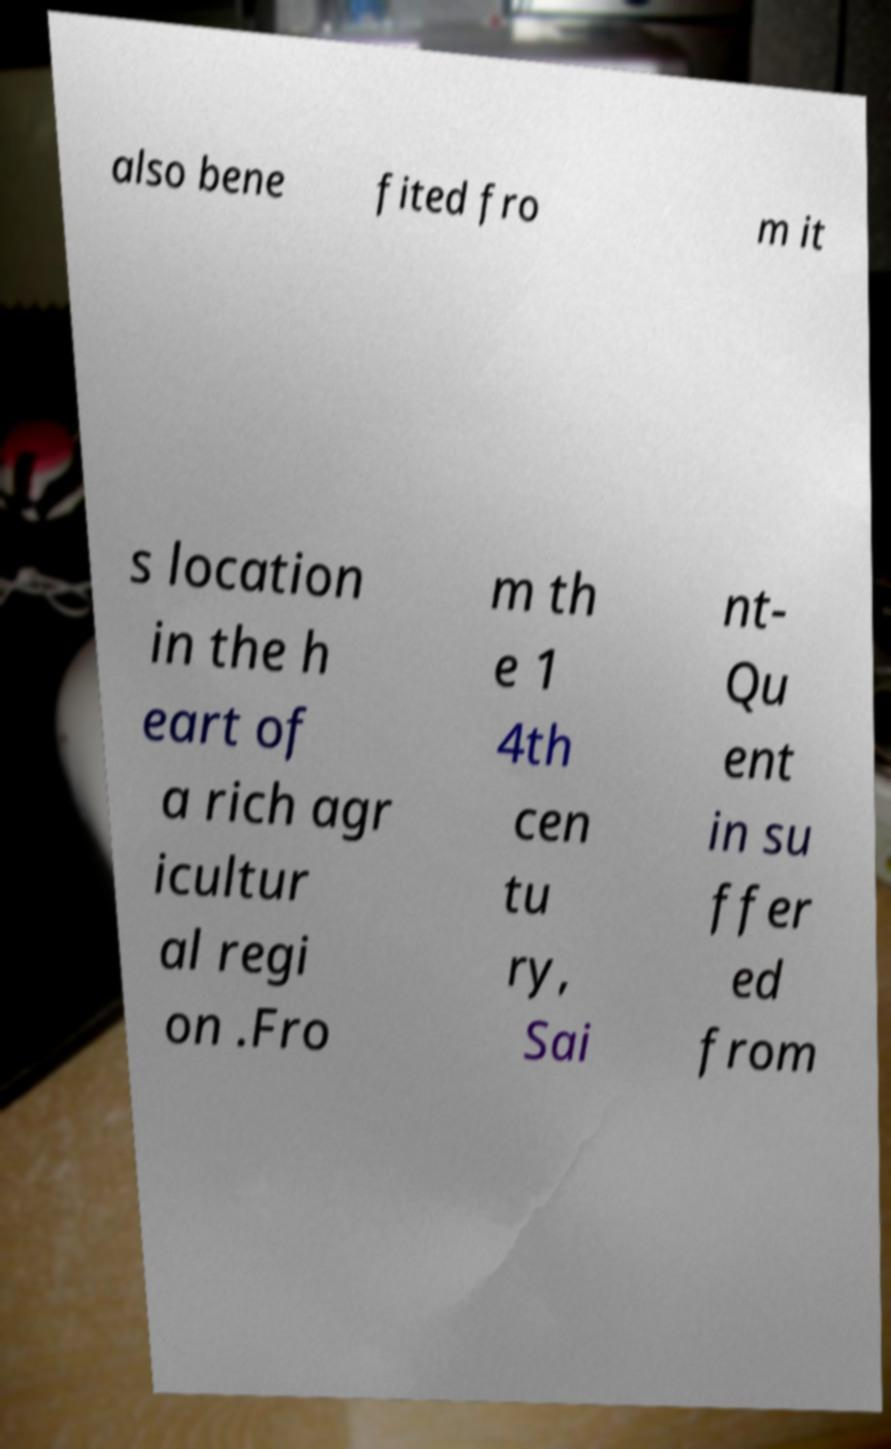Could you assist in decoding the text presented in this image and type it out clearly? also bene fited fro m it s location in the h eart of a rich agr icultur al regi on .Fro m th e 1 4th cen tu ry, Sai nt- Qu ent in su ffer ed from 